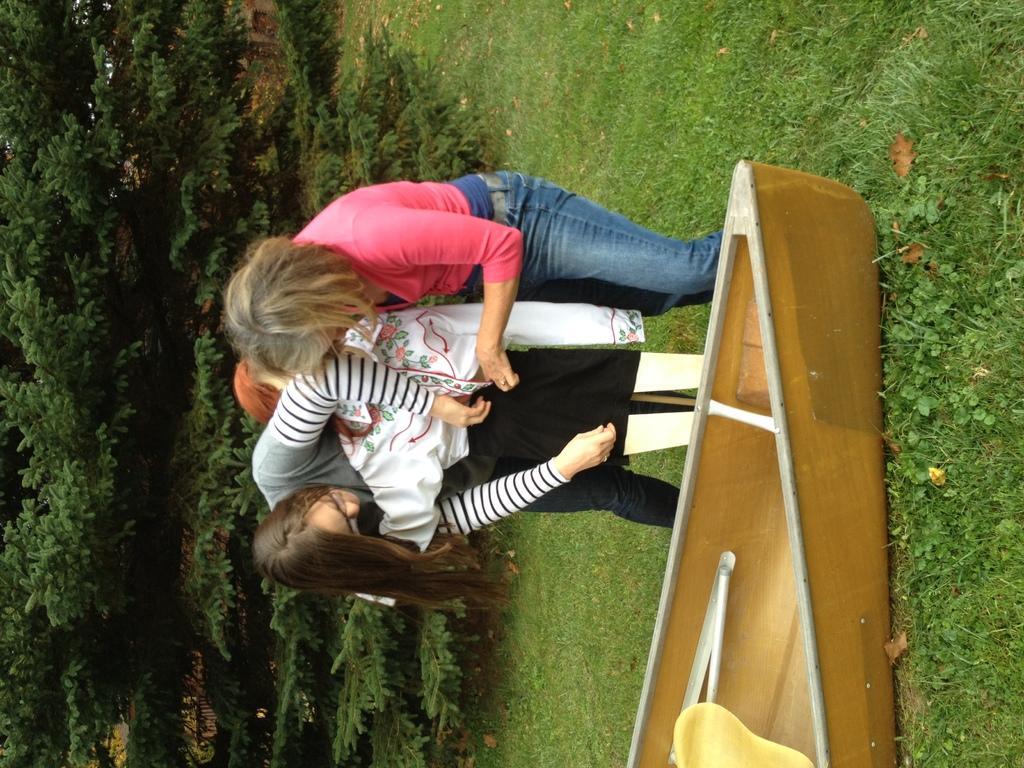In one or two sentences, can you explain what this image depicts? In this image we can see people. There is a boat on the grass which is truncated. On the left side of the image we can see plants. 